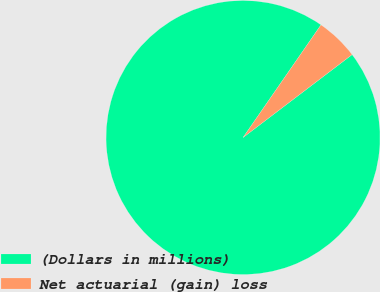<chart> <loc_0><loc_0><loc_500><loc_500><pie_chart><fcel>(Dollars in millions)<fcel>Net actuarial (gain) loss<nl><fcel>94.98%<fcel>5.02%<nl></chart> 